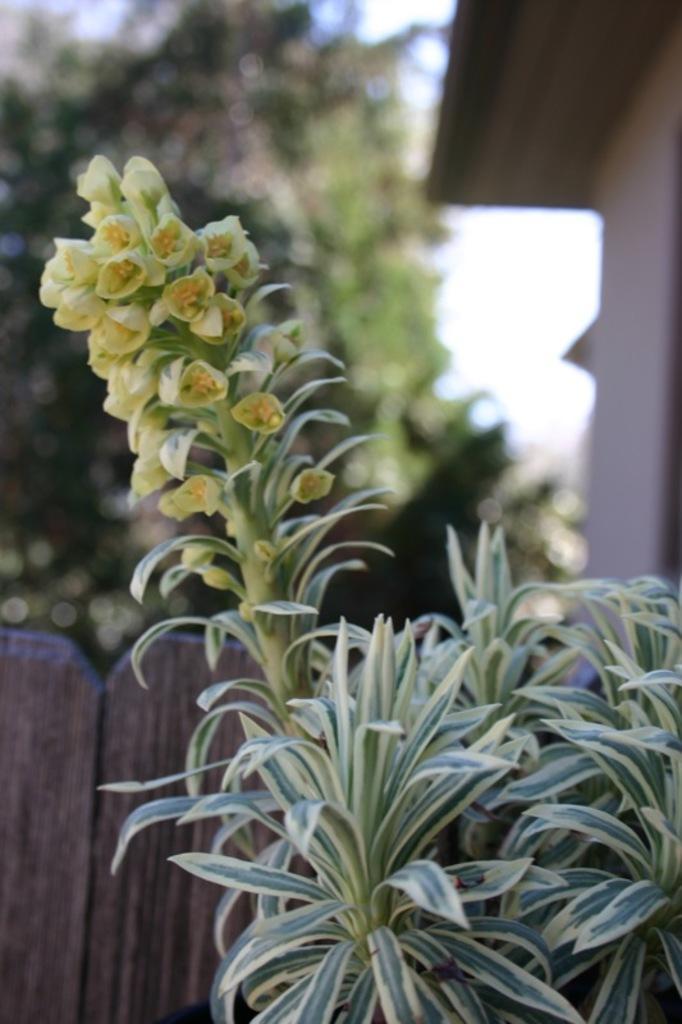Please provide a concise description of this image. In this image in the foreground there are some flowers and plants and, in the background there is a wooden fence, trees and one house. 